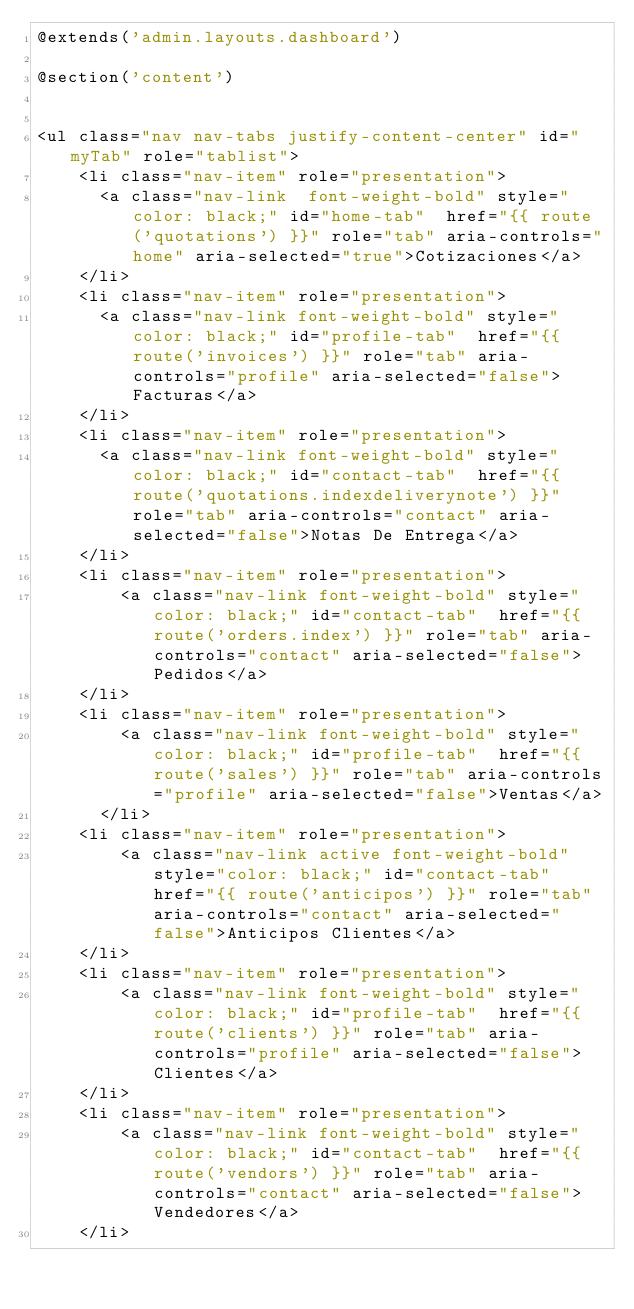Convert code to text. <code><loc_0><loc_0><loc_500><loc_500><_PHP_>@extends('admin.layouts.dashboard')

@section('content')

   
<ul class="nav nav-tabs justify-content-center" id="myTab" role="tablist">
    <li class="nav-item" role="presentation">
      <a class="nav-link  font-weight-bold" style="color: black;" id="home-tab"  href="{{ route('quotations') }}" role="tab" aria-controls="home" aria-selected="true">Cotizaciones</a>
    </li>
    <li class="nav-item" role="presentation">
      <a class="nav-link font-weight-bold" style="color: black;" id="profile-tab"  href="{{ route('invoices') }}" role="tab" aria-controls="profile" aria-selected="false">Facturas</a>
    </li>
    <li class="nav-item" role="presentation">
      <a class="nav-link font-weight-bold" style="color: black;" id="contact-tab"  href="{{ route('quotations.indexdeliverynote') }}" role="tab" aria-controls="contact" aria-selected="false">Notas De Entrega</a>
    </li>
    <li class="nav-item" role="presentation">
        <a class="nav-link font-weight-bold" style="color: black;" id="contact-tab"  href="{{ route('orders.index') }}" role="tab" aria-controls="contact" aria-selected="false">Pedidos</a>
    </li>
    <li class="nav-item" role="presentation">
        <a class="nav-link font-weight-bold" style="color: black;" id="profile-tab"  href="{{ route('sales') }}" role="tab" aria-controls="profile" aria-selected="false">Ventas</a>
      </li>
    <li class="nav-item" role="presentation">
        <a class="nav-link active font-weight-bold" style="color: black;" id="contact-tab"  href="{{ route('anticipos') }}" role="tab" aria-controls="contact" aria-selected="false">Anticipos Clientes</a>
    </li>
    <li class="nav-item" role="presentation">
        <a class="nav-link font-weight-bold" style="color: black;" id="profile-tab"  href="{{ route('clients') }}" role="tab" aria-controls="profile" aria-selected="false">Clientes</a>
    </li>
    <li class="nav-item" role="presentation">
        <a class="nav-link font-weight-bold" style="color: black;" id="contact-tab"  href="{{ route('vendors') }}" role="tab" aria-controls="contact" aria-selected="false">Vendedores</a>
    </li></code> 